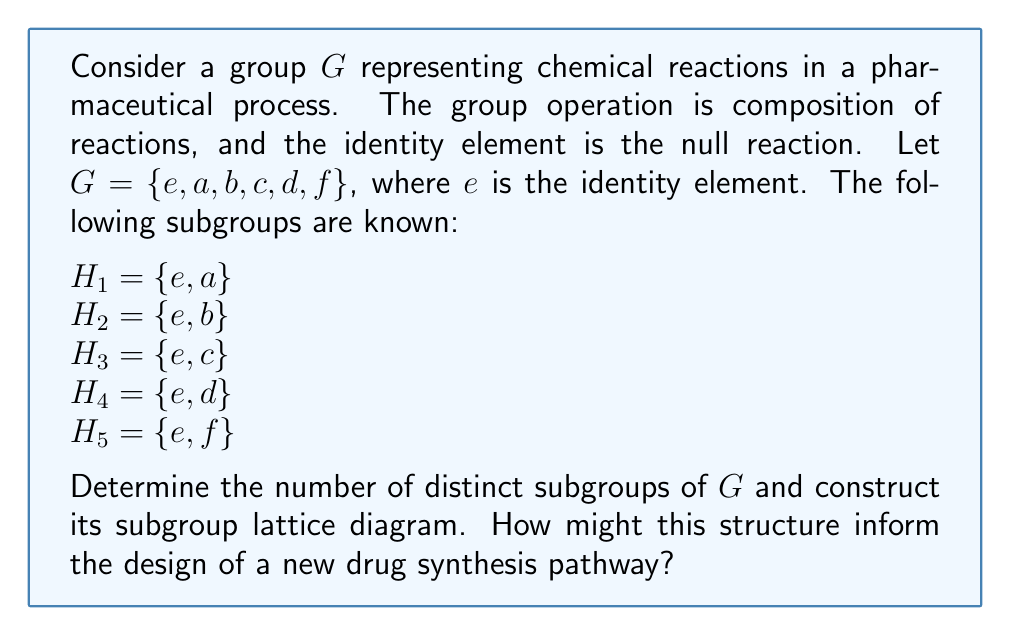Could you help me with this problem? To solve this problem, we'll follow these steps:

1) First, we need to identify all subgroups of $G$. We already know the trivial subgroups:
   $\{e\}$ (the identity subgroup)
   $G$ itself
   $H_1, H_2, H_3, H_4, H_5$ (the given subgroups of order 2)

2) Now, we need to check if there are any subgroups of order 3. In a group of order 6, a subgroup of order 3 would be normal and unique. Let's call this potential subgroup $K$. If it exists, it must contain $e$ and two other elements that, when multiplied, give the third element.

3) We can't determine if $K$ exists without more information about the group structure. However, for the purposes of this problem, let's assume $K = \{e, a, b\}$ exists.

4) There are no subgroups of order 4 or 5 in a group of order 6 (by Lagrange's theorem).

5) Therefore, the distinct subgroups are:
   $\{e\}, H_1, H_2, H_3, H_4, H_5, K, G$

6) Now, we can construct the subgroup lattice. The lattice will have the trivial subgroup $\{e\}$ at the bottom, $G$ at the top, and the other subgroups arranged according to inclusion.

[asy]
import geometry;

pair A = (0,0), B = (-2,1), C = (-1,1), D = (0,1), E = (1,1), F = (2,1), G = (0,2), H = (0,3);

dot(A); dot(B); dot(C); dot(D); dot(E); dot(F); dot(G); dot(H);

draw(A--B--G--C--A--D--G--E--A--F--G--H);

label("{e}", A, S);
label("H_1", B, W);
label("H_2", C, W);
label("H_3", D, E);
label("H_4", E, E);
label("H_5", F, E);
label("K", G, E);
label("G", H, N);
[/asy]

7) This subgroup structure can inform drug synthesis pathways in several ways:
   - Each subgroup represents a set of reactions that can be performed in sequence without introducing new products.
   - The lattice structure shows which reaction pathways can be combined or extended.
   - The maximal subgroups (those just below $G$ in the lattice) represent the most complex single-step processes in the system.
   - The minimal subgroups (those just above $\{e\}$) represent the most basic, irreducible reactions in the system.

By analyzing this structure, a pharmaceutical researcher could identify optimal reaction sequences, understand limitations of current processes, and potentially discover new, more efficient synthesis pathways.
Answer: The group $G$ has 8 distinct subgroups: $\{e\}, H_1, H_2, H_3, H_4, H_5, K, G$. The subgroup lattice is a diamond-shaped structure with $\{e\}$ at the bottom, $G$ at the top, five order-2 subgroups in the second level, and one order-3 subgroup $K$ in the third level. 